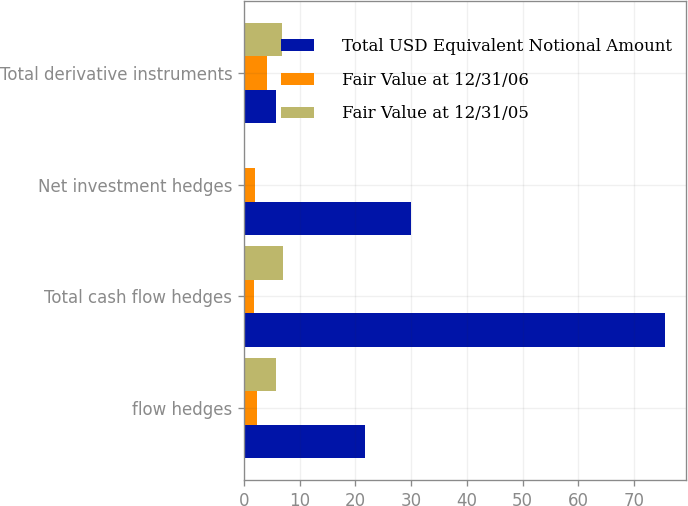Convert chart. <chart><loc_0><loc_0><loc_500><loc_500><stacked_bar_chart><ecel><fcel>flow hedges<fcel>Total cash flow hedges<fcel>Net investment hedges<fcel>Total derivative instruments<nl><fcel>Total USD Equivalent Notional Amount<fcel>21.8<fcel>75.6<fcel>30<fcel>5.7<nl><fcel>Fair Value at 12/31/06<fcel>2.4<fcel>1.8<fcel>1.9<fcel>4.1<nl><fcel>Fair Value at 12/31/05<fcel>5.7<fcel>7<fcel>0.2<fcel>6.8<nl></chart> 